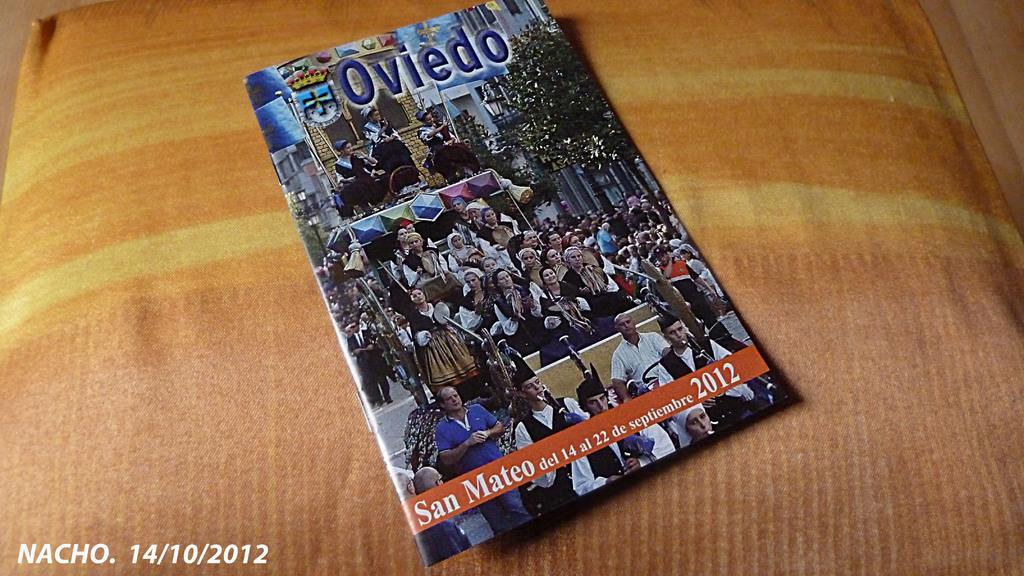<image>
Relay a brief, clear account of the picture shown. Oviedo magazine is laying on a bed with a pink cover 